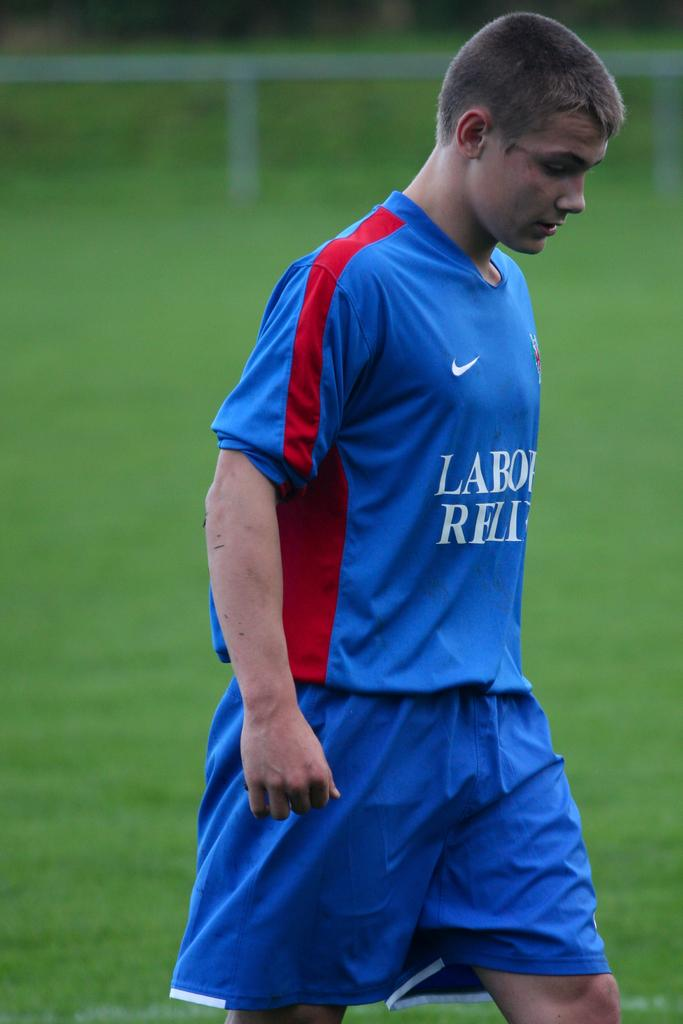What is present in the image? There is a person in the image. What is the person wearing? The person is wearing a blue t-shirt. Where is the person located in the image? The person is visible on the ground. What type of drain can be seen in the image? There is no drain present in the image. What mark is visible on the person's face in the image? There is no mark visible on the person's face in the image. 